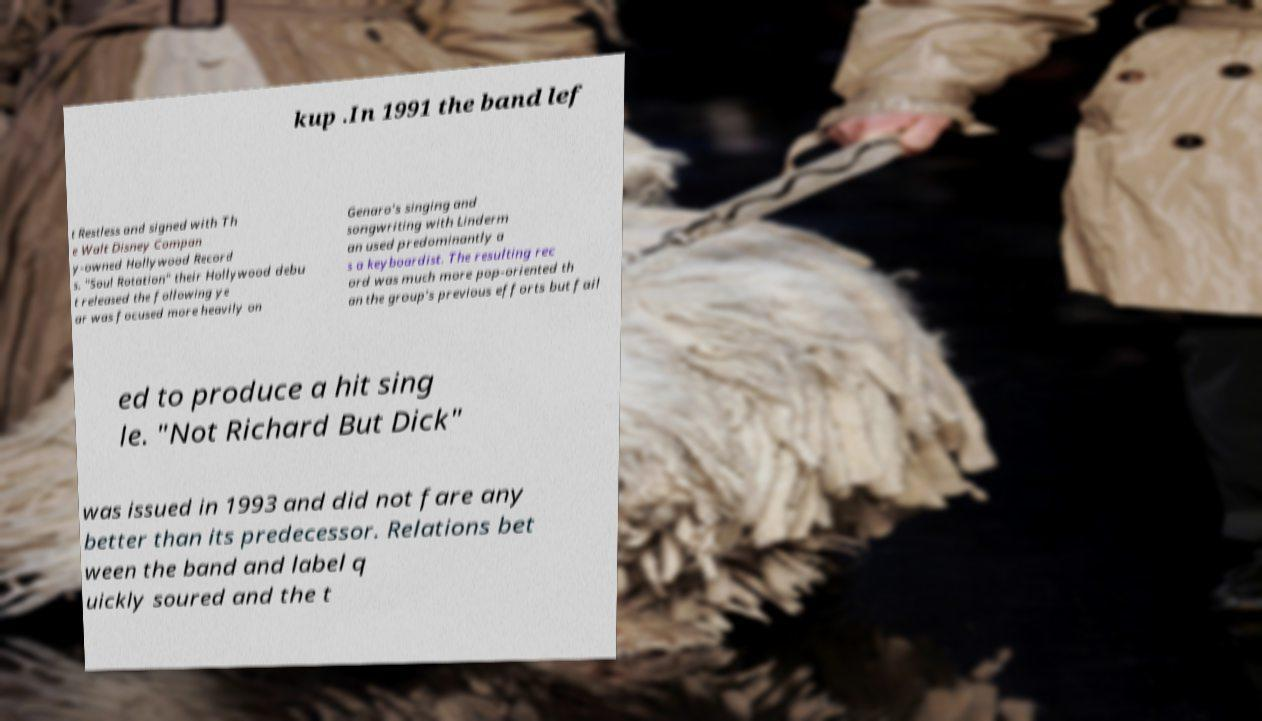Can you accurately transcribe the text from the provided image for me? kup .In 1991 the band lef t Restless and signed with Th e Walt Disney Compan y-owned Hollywood Record s. "Soul Rotation" their Hollywood debu t released the following ye ar was focused more heavily on Genaro's singing and songwriting with Linderm an used predominantly a s a keyboardist. The resulting rec ord was much more pop-oriented th an the group's previous efforts but fail ed to produce a hit sing le. "Not Richard But Dick" was issued in 1993 and did not fare any better than its predecessor. Relations bet ween the band and label q uickly soured and the t 